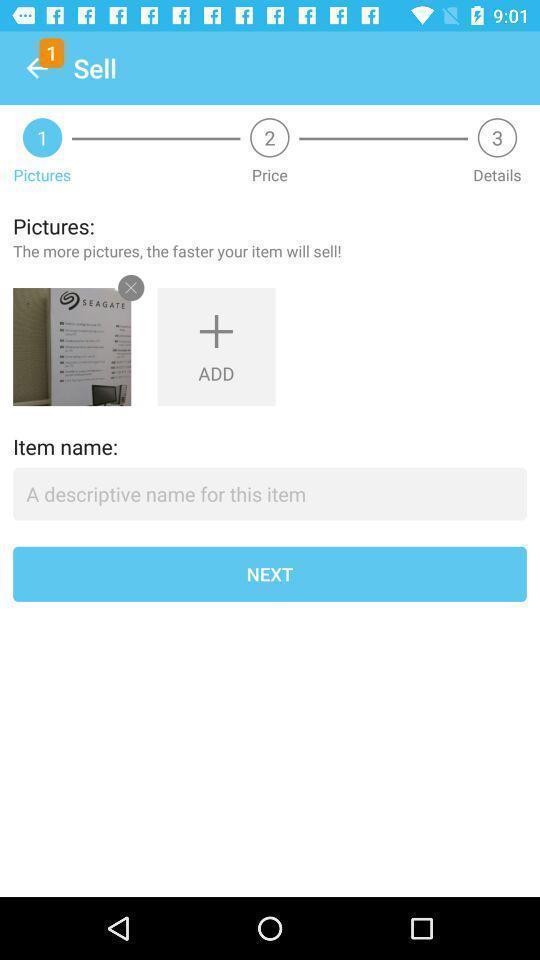Provide a detailed account of this screenshot. Screen showing add picture page of a shopping app. 